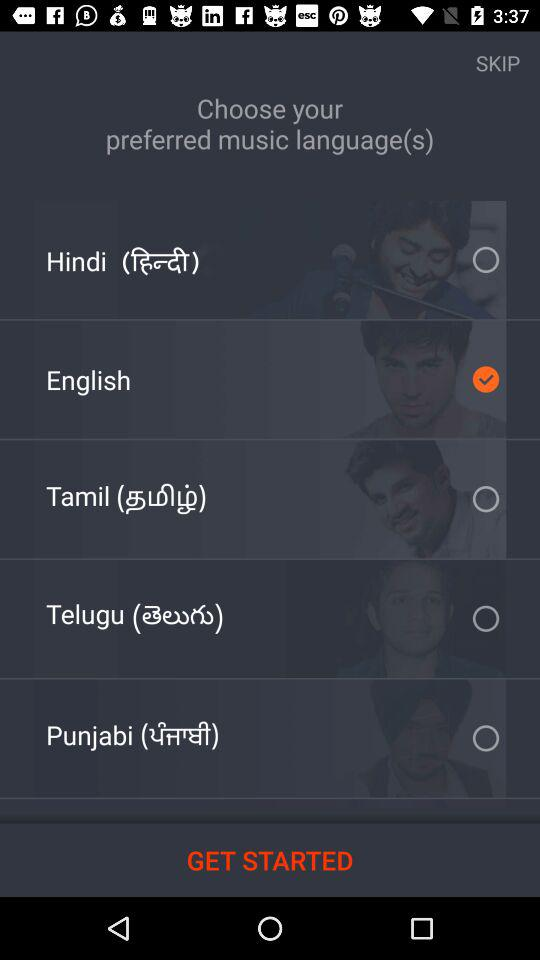How many languages are there to choose from?
Answer the question using a single word or phrase. 5 